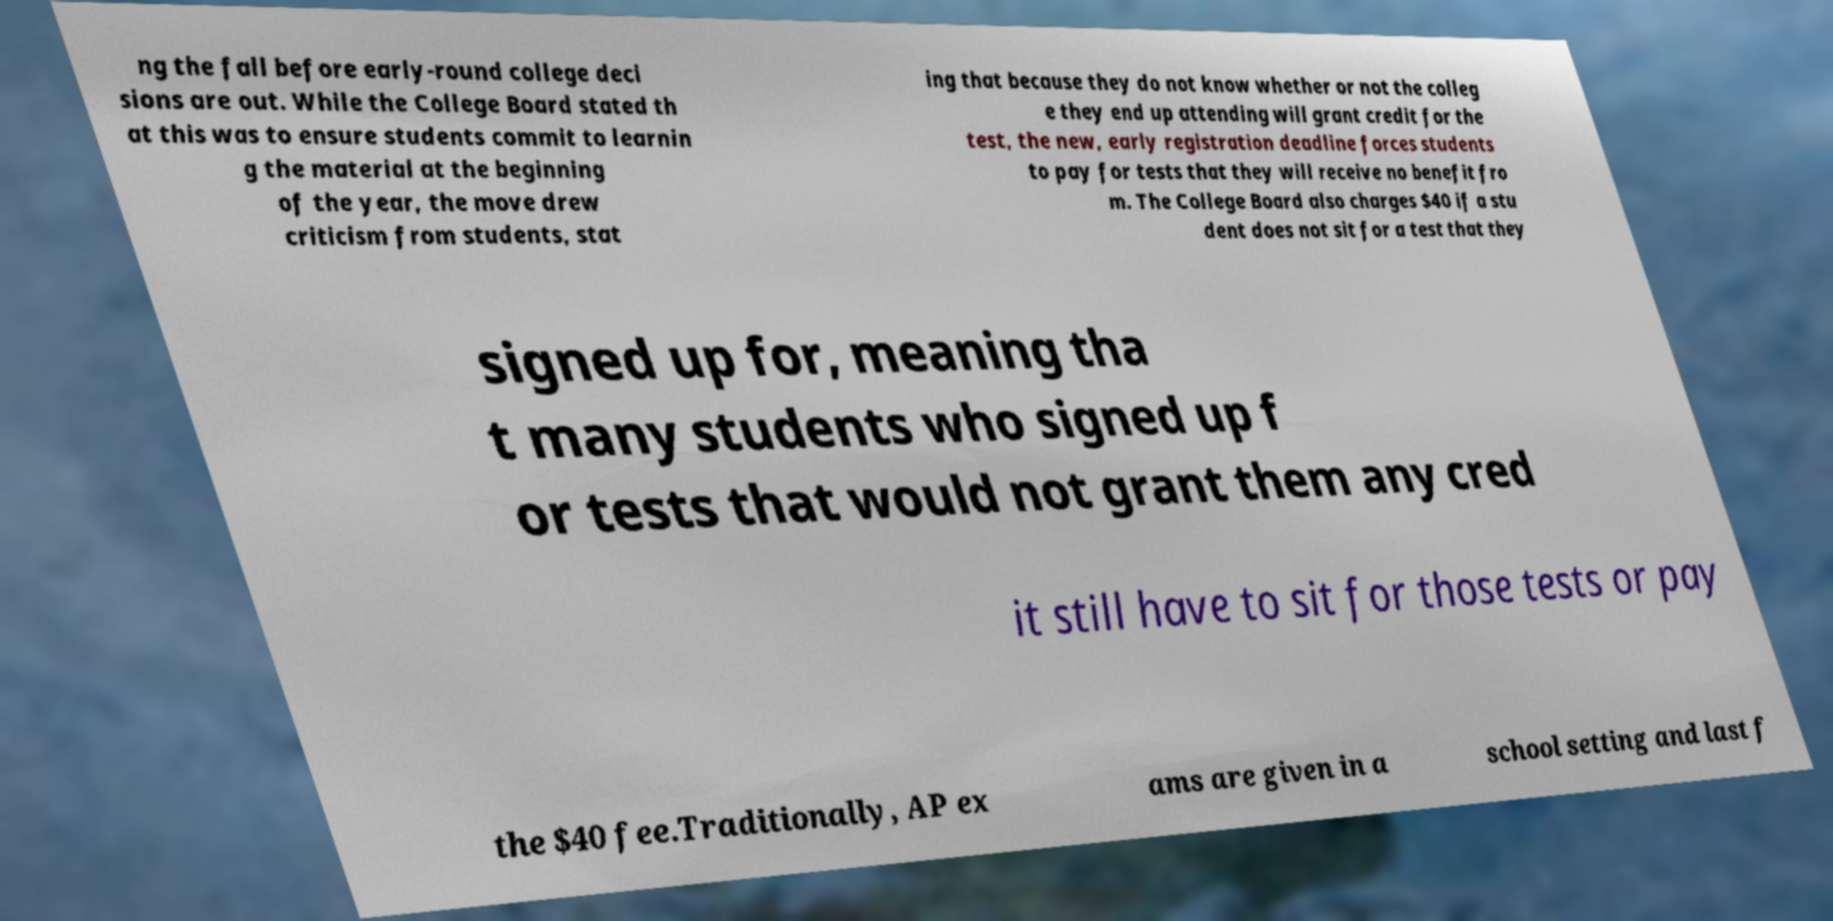Can you accurately transcribe the text from the provided image for me? ng the fall before early-round college deci sions are out. While the College Board stated th at this was to ensure students commit to learnin g the material at the beginning of the year, the move drew criticism from students, stat ing that because they do not know whether or not the colleg e they end up attending will grant credit for the test, the new, early registration deadline forces students to pay for tests that they will receive no benefit fro m. The College Board also charges $40 if a stu dent does not sit for a test that they signed up for, meaning tha t many students who signed up f or tests that would not grant them any cred it still have to sit for those tests or pay the $40 fee.Traditionally, AP ex ams are given in a school setting and last f 